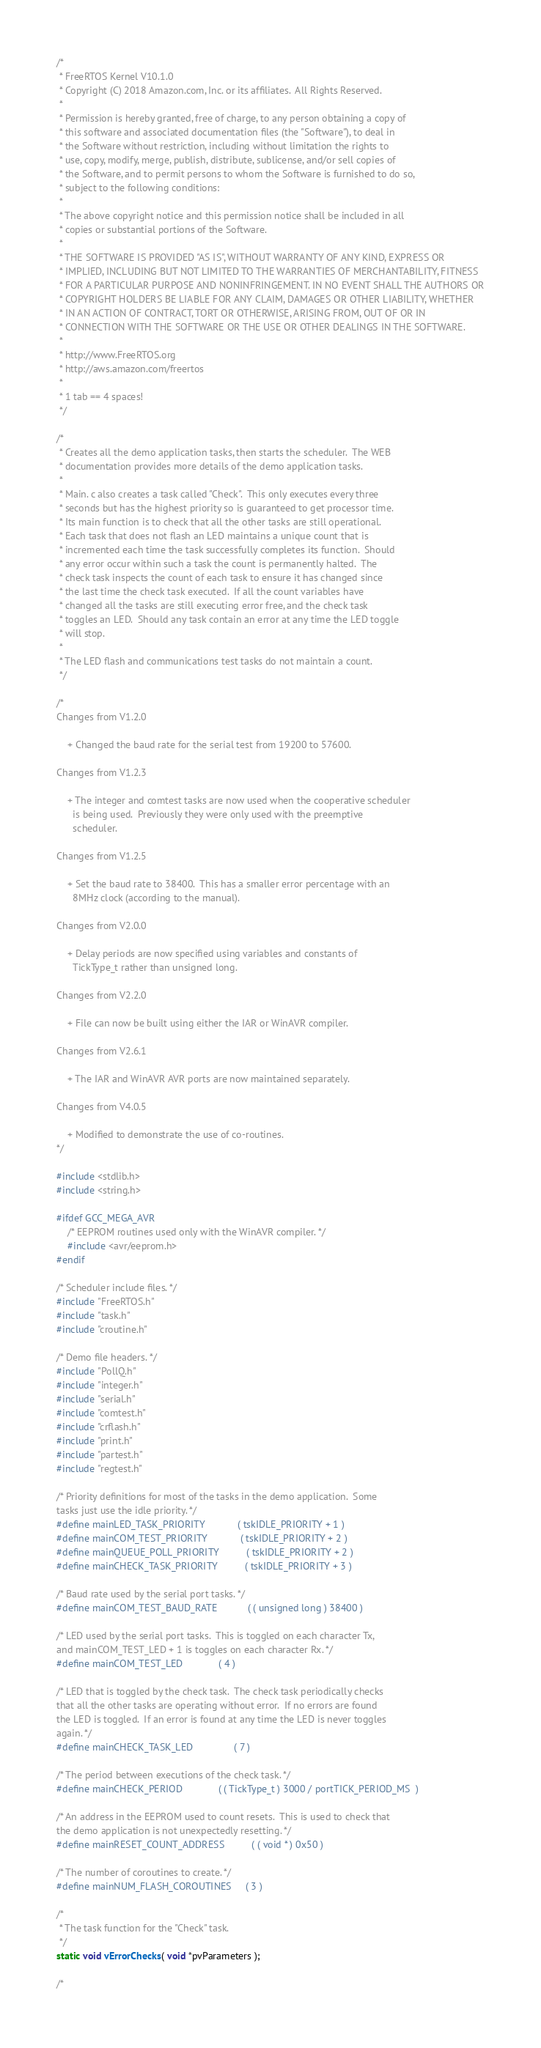<code> <loc_0><loc_0><loc_500><loc_500><_C_>/*
 * FreeRTOS Kernel V10.1.0
 * Copyright (C) 2018 Amazon.com, Inc. or its affiliates.  All Rights Reserved.
 *
 * Permission is hereby granted, free of charge, to any person obtaining a copy of
 * this software and associated documentation files (the "Software"), to deal in
 * the Software without restriction, including without limitation the rights to
 * use, copy, modify, merge, publish, distribute, sublicense, and/or sell copies of
 * the Software, and to permit persons to whom the Software is furnished to do so,
 * subject to the following conditions:
 *
 * The above copyright notice and this permission notice shall be included in all
 * copies or substantial portions of the Software.
 *
 * THE SOFTWARE IS PROVIDED "AS IS", WITHOUT WARRANTY OF ANY KIND, EXPRESS OR
 * IMPLIED, INCLUDING BUT NOT LIMITED TO THE WARRANTIES OF MERCHANTABILITY, FITNESS
 * FOR A PARTICULAR PURPOSE AND NONINFRINGEMENT. IN NO EVENT SHALL THE AUTHORS OR
 * COPYRIGHT HOLDERS BE LIABLE FOR ANY CLAIM, DAMAGES OR OTHER LIABILITY, WHETHER
 * IN AN ACTION OF CONTRACT, TORT OR OTHERWISE, ARISING FROM, OUT OF OR IN
 * CONNECTION WITH THE SOFTWARE OR THE USE OR OTHER DEALINGS IN THE SOFTWARE.
 *
 * http://www.FreeRTOS.org
 * http://aws.amazon.com/freertos
 *
 * 1 tab == 4 spaces!
 */

/*
 * Creates all the demo application tasks, then starts the scheduler.  The WEB
 * documentation provides more details of the demo application tasks.
 *
 * Main. c also creates a task called "Check".  This only executes every three
 * seconds but has the highest priority so is guaranteed to get processor time.
 * Its main function is to check that all the other tasks are still operational.
 * Each task that does not flash an LED maintains a unique count that is
 * incremented each time the task successfully completes its function.  Should
 * any error occur within such a task the count is permanently halted.  The
 * check task inspects the count of each task to ensure it has changed since
 * the last time the check task executed.  If all the count variables have
 * changed all the tasks are still executing error free, and the check task
 * toggles an LED.  Should any task contain an error at any time the LED toggle
 * will stop.
 *
 * The LED flash and communications test tasks do not maintain a count.
 */

/*
Changes from V1.2.0
	
	+ Changed the baud rate for the serial test from 19200 to 57600.

Changes from V1.2.3

	+ The integer and comtest tasks are now used when the cooperative scheduler
	  is being used.  Previously they were only used with the preemptive
	  scheduler.

Changes from V1.2.5

	+ Set the baud rate to 38400.  This has a smaller error percentage with an
	  8MHz clock (according to the manual).

Changes from V2.0.0

	+ Delay periods are now specified using variables and constants of
	  TickType_t rather than unsigned long.

Changes from V2.2.0

	+ File can now be built using either the IAR or WinAVR compiler.

Changes from V2.6.1

	+ The IAR and WinAVR AVR ports are now maintained separately.

Changes from V4.0.5

	+ Modified to demonstrate the use of co-routines.
*/

#include <stdlib.h>
#include <string.h>

#ifdef GCC_MEGA_AVR
	/* EEPROM routines used only with the WinAVR compiler. */
	#include <avr/eeprom.h>
#endif

/* Scheduler include files. */
#include "FreeRTOS.h"
#include "task.h"
#include "croutine.h"

/* Demo file headers. */
#include "PollQ.h"
#include "integer.h"
#include "serial.h"
#include "comtest.h"
#include "crflash.h"
#include "print.h"
#include "partest.h"
#include "regtest.h"

/* Priority definitions for most of the tasks in the demo application.  Some
tasks just use the idle priority. */
#define mainLED_TASK_PRIORITY			( tskIDLE_PRIORITY + 1 )
#define mainCOM_TEST_PRIORITY			( tskIDLE_PRIORITY + 2 )
#define mainQUEUE_POLL_PRIORITY			( tskIDLE_PRIORITY + 2 )
#define mainCHECK_TASK_PRIORITY			( tskIDLE_PRIORITY + 3 )

/* Baud rate used by the serial port tasks. */
#define mainCOM_TEST_BAUD_RATE			( ( unsigned long ) 38400 )

/* LED used by the serial port tasks.  This is toggled on each character Tx,
and mainCOM_TEST_LED + 1 is toggles on each character Rx. */
#define mainCOM_TEST_LED				( 4 )

/* LED that is toggled by the check task.  The check task periodically checks
that all the other tasks are operating without error.  If no errors are found
the LED is toggled.  If an error is found at any time the LED is never toggles
again. */
#define mainCHECK_TASK_LED				( 7 )

/* The period between executions of the check task. */
#define mainCHECK_PERIOD				( ( TickType_t ) 3000 / portTICK_PERIOD_MS  )

/* An address in the EEPROM used to count resets.  This is used to check that
the demo application is not unexpectedly resetting. */
#define mainRESET_COUNT_ADDRESS			( ( void * ) 0x50 )

/* The number of coroutines to create. */
#define mainNUM_FLASH_COROUTINES		( 3 )

/*
 * The task function for the "Check" task.
 */
static void vErrorChecks( void *pvParameters );

/*</code> 